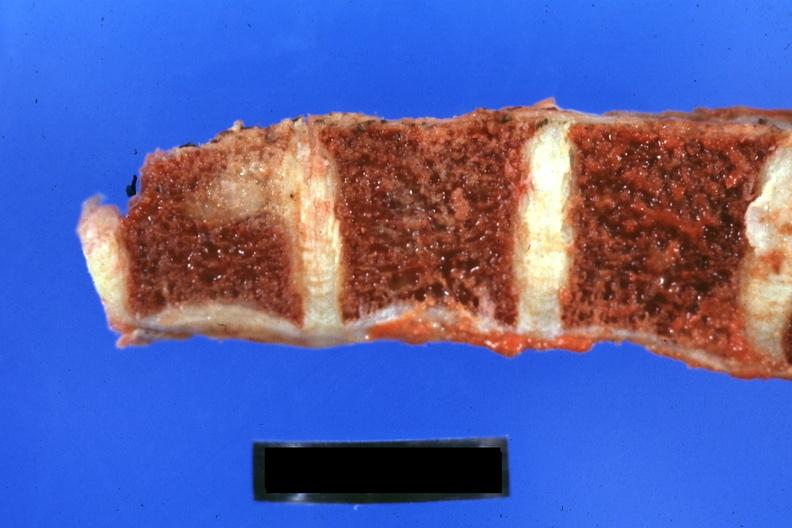how much of lung giant cell type occurring 25 years after she was treat-ed for hodgkins disease?
Answer the question using a single word or phrase. 44yobfadenocarcinoma 